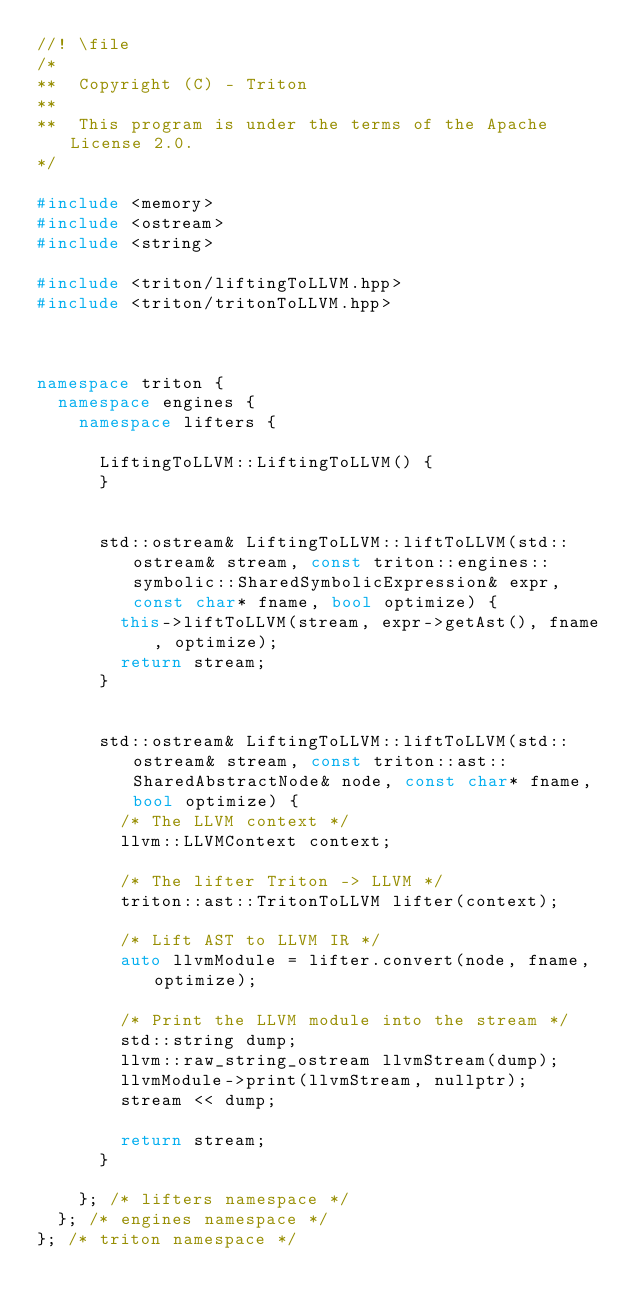Convert code to text. <code><loc_0><loc_0><loc_500><loc_500><_C++_>//! \file
/*
**  Copyright (C) - Triton
**
**  This program is under the terms of the Apache License 2.0.
*/

#include <memory>
#include <ostream>
#include <string>

#include <triton/liftingToLLVM.hpp>
#include <triton/tritonToLLVM.hpp>



namespace triton {
  namespace engines {
    namespace lifters {

      LiftingToLLVM::LiftingToLLVM() {
      }


      std::ostream& LiftingToLLVM::liftToLLVM(std::ostream& stream, const triton::engines::symbolic::SharedSymbolicExpression& expr, const char* fname, bool optimize) {
        this->liftToLLVM(stream, expr->getAst(), fname, optimize);
        return stream;
      }


      std::ostream& LiftingToLLVM::liftToLLVM(std::ostream& stream, const triton::ast::SharedAbstractNode& node, const char* fname, bool optimize) {
        /* The LLVM context */
        llvm::LLVMContext context;

        /* The lifter Triton -> LLVM */
        triton::ast::TritonToLLVM lifter(context);

        /* Lift AST to LLVM IR */
        auto llvmModule = lifter.convert(node, fname, optimize);

        /* Print the LLVM module into the stream */
        std::string dump;
        llvm::raw_string_ostream llvmStream(dump);
        llvmModule->print(llvmStream, nullptr);
        stream << dump;

        return stream;
      }

    }; /* lifters namespace */
  }; /* engines namespace */
}; /* triton namespace */
</code> 